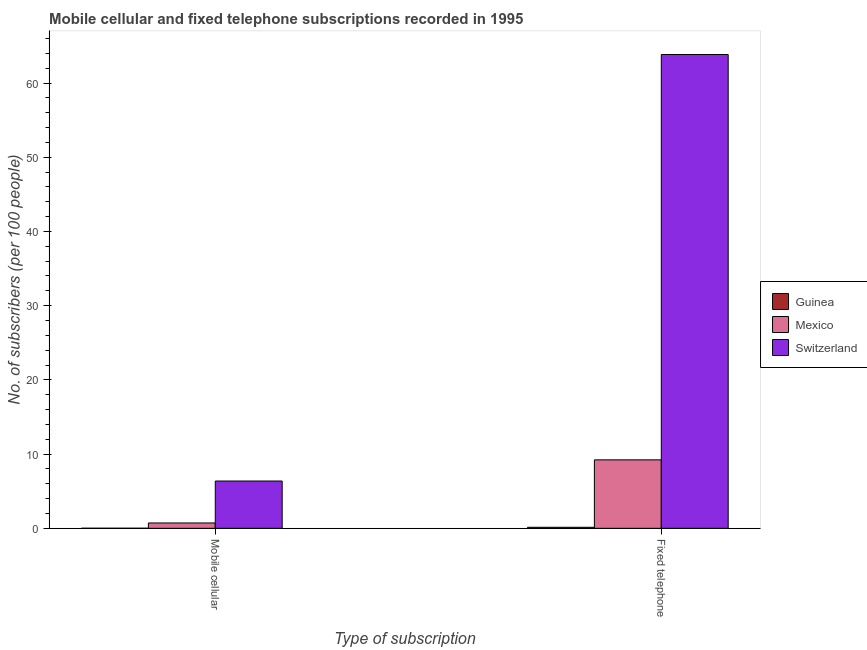How many different coloured bars are there?
Give a very brief answer. 3. How many groups of bars are there?
Offer a terse response. 2. Are the number of bars on each tick of the X-axis equal?
Provide a short and direct response. Yes. What is the label of the 2nd group of bars from the left?
Make the answer very short. Fixed telephone. What is the number of mobile cellular subscribers in Mexico?
Ensure brevity in your answer.  0.72. Across all countries, what is the maximum number of mobile cellular subscribers?
Keep it short and to the point. 6.37. Across all countries, what is the minimum number of mobile cellular subscribers?
Your answer should be compact. 0.01. In which country was the number of fixed telephone subscribers maximum?
Provide a succinct answer. Switzerland. In which country was the number of fixed telephone subscribers minimum?
Provide a succinct answer. Guinea. What is the total number of fixed telephone subscribers in the graph?
Give a very brief answer. 73.21. What is the difference between the number of fixed telephone subscribers in Mexico and that in Switzerland?
Offer a terse response. -54.62. What is the difference between the number of mobile cellular subscribers in Mexico and the number of fixed telephone subscribers in Guinea?
Your answer should be very brief. 0.58. What is the average number of fixed telephone subscribers per country?
Provide a succinct answer. 24.4. What is the difference between the number of mobile cellular subscribers and number of fixed telephone subscribers in Guinea?
Your answer should be very brief. -0.13. What is the ratio of the number of mobile cellular subscribers in Guinea to that in Mexico?
Provide a succinct answer. 0.02. In how many countries, is the number of fixed telephone subscribers greater than the average number of fixed telephone subscribers taken over all countries?
Your answer should be very brief. 1. What does the 3rd bar from the left in Fixed telephone represents?
Your answer should be compact. Switzerland. How many bars are there?
Offer a terse response. 6. Are all the bars in the graph horizontal?
Your answer should be very brief. No. How many countries are there in the graph?
Ensure brevity in your answer.  3. Does the graph contain any zero values?
Provide a succinct answer. No. Where does the legend appear in the graph?
Provide a short and direct response. Center right. How are the legend labels stacked?
Provide a short and direct response. Vertical. What is the title of the graph?
Ensure brevity in your answer.  Mobile cellular and fixed telephone subscriptions recorded in 1995. What is the label or title of the X-axis?
Your response must be concise. Type of subscription. What is the label or title of the Y-axis?
Keep it short and to the point. No. of subscribers (per 100 people). What is the No. of subscribers (per 100 people) in Guinea in Mobile cellular?
Keep it short and to the point. 0.01. What is the No. of subscribers (per 100 people) of Mexico in Mobile cellular?
Your response must be concise. 0.72. What is the No. of subscribers (per 100 people) of Switzerland in Mobile cellular?
Make the answer very short. 6.37. What is the No. of subscribers (per 100 people) in Guinea in Fixed telephone?
Give a very brief answer. 0.14. What is the No. of subscribers (per 100 people) in Mexico in Fixed telephone?
Your answer should be compact. 9.23. What is the No. of subscribers (per 100 people) in Switzerland in Fixed telephone?
Give a very brief answer. 63.84. Across all Type of subscription, what is the maximum No. of subscribers (per 100 people) in Guinea?
Offer a terse response. 0.14. Across all Type of subscription, what is the maximum No. of subscribers (per 100 people) of Mexico?
Ensure brevity in your answer.  9.23. Across all Type of subscription, what is the maximum No. of subscribers (per 100 people) in Switzerland?
Give a very brief answer. 63.84. Across all Type of subscription, what is the minimum No. of subscribers (per 100 people) in Guinea?
Offer a very short reply. 0.01. Across all Type of subscription, what is the minimum No. of subscribers (per 100 people) of Mexico?
Give a very brief answer. 0.72. Across all Type of subscription, what is the minimum No. of subscribers (per 100 people) of Switzerland?
Offer a very short reply. 6.37. What is the total No. of subscribers (per 100 people) in Guinea in the graph?
Offer a very short reply. 0.15. What is the total No. of subscribers (per 100 people) of Mexico in the graph?
Offer a terse response. 9.95. What is the total No. of subscribers (per 100 people) in Switzerland in the graph?
Provide a succinct answer. 70.22. What is the difference between the No. of subscribers (per 100 people) in Guinea in Mobile cellular and that in Fixed telephone?
Offer a terse response. -0.13. What is the difference between the No. of subscribers (per 100 people) in Mexico in Mobile cellular and that in Fixed telephone?
Your answer should be very brief. -8.5. What is the difference between the No. of subscribers (per 100 people) in Switzerland in Mobile cellular and that in Fixed telephone?
Offer a terse response. -57.47. What is the difference between the No. of subscribers (per 100 people) of Guinea in Mobile cellular and the No. of subscribers (per 100 people) of Mexico in Fixed telephone?
Your answer should be compact. -9.21. What is the difference between the No. of subscribers (per 100 people) in Guinea in Mobile cellular and the No. of subscribers (per 100 people) in Switzerland in Fixed telephone?
Make the answer very short. -63.83. What is the difference between the No. of subscribers (per 100 people) in Mexico in Mobile cellular and the No. of subscribers (per 100 people) in Switzerland in Fixed telephone?
Give a very brief answer. -63.12. What is the average No. of subscribers (per 100 people) of Guinea per Type of subscription?
Offer a terse response. 0.08. What is the average No. of subscribers (per 100 people) of Mexico per Type of subscription?
Offer a very short reply. 4.97. What is the average No. of subscribers (per 100 people) in Switzerland per Type of subscription?
Ensure brevity in your answer.  35.11. What is the difference between the No. of subscribers (per 100 people) in Guinea and No. of subscribers (per 100 people) in Mexico in Mobile cellular?
Provide a short and direct response. -0.71. What is the difference between the No. of subscribers (per 100 people) of Guinea and No. of subscribers (per 100 people) of Switzerland in Mobile cellular?
Keep it short and to the point. -6.36. What is the difference between the No. of subscribers (per 100 people) in Mexico and No. of subscribers (per 100 people) in Switzerland in Mobile cellular?
Your answer should be compact. -5.65. What is the difference between the No. of subscribers (per 100 people) in Guinea and No. of subscribers (per 100 people) in Mexico in Fixed telephone?
Offer a terse response. -9.09. What is the difference between the No. of subscribers (per 100 people) in Guinea and No. of subscribers (per 100 people) in Switzerland in Fixed telephone?
Ensure brevity in your answer.  -63.71. What is the difference between the No. of subscribers (per 100 people) in Mexico and No. of subscribers (per 100 people) in Switzerland in Fixed telephone?
Your response must be concise. -54.62. What is the ratio of the No. of subscribers (per 100 people) in Guinea in Mobile cellular to that in Fixed telephone?
Provide a succinct answer. 0.09. What is the ratio of the No. of subscribers (per 100 people) in Mexico in Mobile cellular to that in Fixed telephone?
Keep it short and to the point. 0.08. What is the ratio of the No. of subscribers (per 100 people) in Switzerland in Mobile cellular to that in Fixed telephone?
Your response must be concise. 0.1. What is the difference between the highest and the second highest No. of subscribers (per 100 people) in Guinea?
Give a very brief answer. 0.13. What is the difference between the highest and the second highest No. of subscribers (per 100 people) in Mexico?
Your answer should be very brief. 8.5. What is the difference between the highest and the second highest No. of subscribers (per 100 people) in Switzerland?
Ensure brevity in your answer.  57.47. What is the difference between the highest and the lowest No. of subscribers (per 100 people) of Guinea?
Your answer should be compact. 0.13. What is the difference between the highest and the lowest No. of subscribers (per 100 people) of Mexico?
Keep it short and to the point. 8.5. What is the difference between the highest and the lowest No. of subscribers (per 100 people) in Switzerland?
Ensure brevity in your answer.  57.47. 